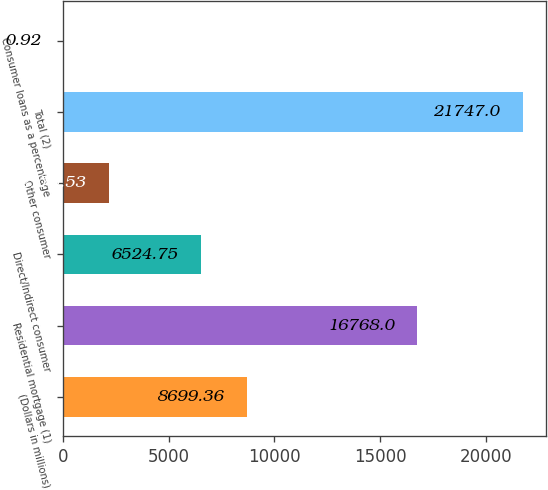Convert chart. <chart><loc_0><loc_0><loc_500><loc_500><bar_chart><fcel>(Dollars in millions)<fcel>Residential mortgage (1)<fcel>Direct/Indirect consumer<fcel>Other consumer<fcel>Total (2)<fcel>Consumer loans as a percentage<nl><fcel>8699.36<fcel>16768<fcel>6524.75<fcel>2175.53<fcel>21747<fcel>0.92<nl></chart> 